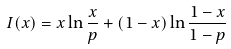Convert formula to latex. <formula><loc_0><loc_0><loc_500><loc_500>I ( x ) = x \ln \frac { x } { p } + ( 1 - x ) \ln \frac { 1 - x } { 1 - p }</formula> 